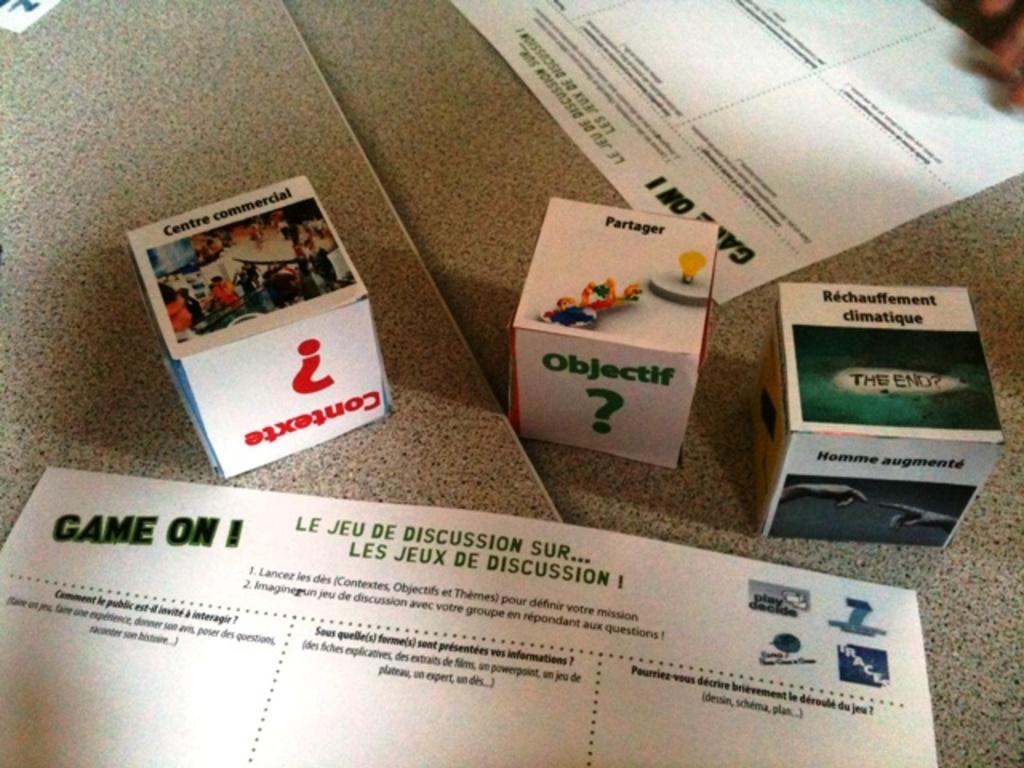<image>
Summarize the visual content of the image. A game with three blocks in a foreign language. 